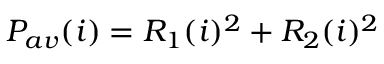Convert formula to latex. <formula><loc_0><loc_0><loc_500><loc_500>P _ { a v } ( i ) = R _ { 1 } ( i ) ^ { 2 } + R _ { 2 } ( i ) ^ { 2 }</formula> 